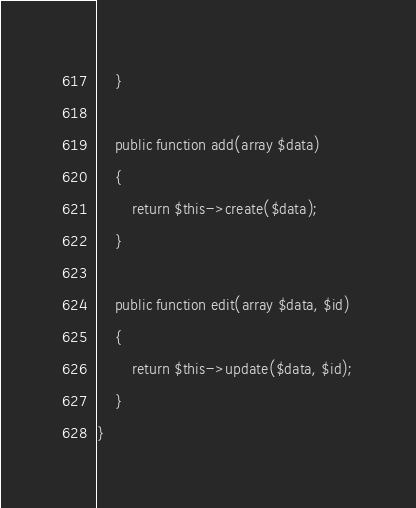<code> <loc_0><loc_0><loc_500><loc_500><_PHP_>    }

    public function add(array $data)
    {
        return $this->create($data);
    }

    public function edit(array $data, $id)
    {
        return $this->update($data, $id);
    }
}</code> 